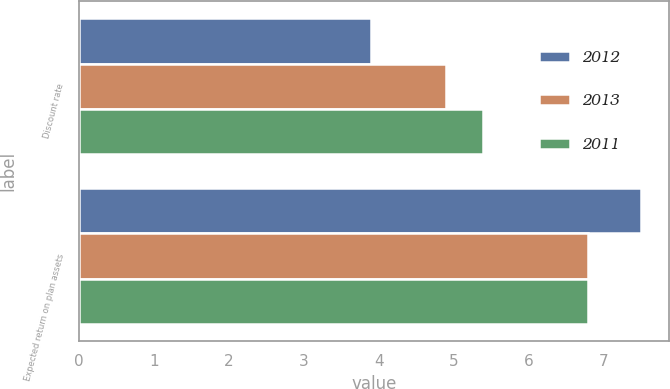Convert chart to OTSL. <chart><loc_0><loc_0><loc_500><loc_500><stacked_bar_chart><ecel><fcel>Discount rate<fcel>Expected return on plan assets<nl><fcel>2012<fcel>3.9<fcel>7.5<nl><fcel>2013<fcel>4.9<fcel>6.8<nl><fcel>2011<fcel>5.4<fcel>6.8<nl></chart> 